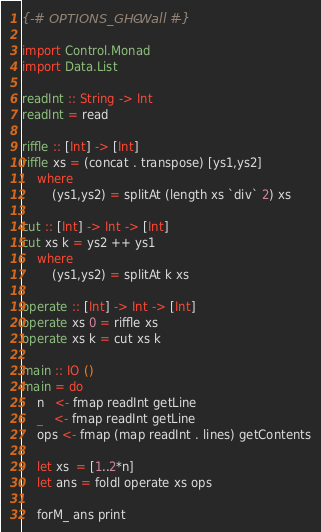Convert code to text. <code><loc_0><loc_0><loc_500><loc_500><_Haskell_>{-# OPTIONS_GHC -Wall #-}

import Control.Monad
import Data.List

readInt :: String -> Int
readInt = read

riffle :: [Int] -> [Int]
riffle xs = (concat . transpose) [ys1,ys2]
    where
        (ys1,ys2) = splitAt (length xs `div` 2) xs

cut :: [Int] -> Int -> [Int]
cut xs k = ys2 ++ ys1
    where
        (ys1,ys2) = splitAt k xs

operate :: [Int] -> Int -> [Int]
operate xs 0 = riffle xs
operate xs k = cut xs k

main :: IO ()
main = do
    n   <- fmap readInt getLine
    _   <- fmap readInt getLine
    ops <- fmap (map readInt . lines) getContents

    let xs  = [1..2*n]
    let ans = foldl operate xs ops

    forM_ ans print

</code> 